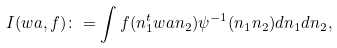<formula> <loc_0><loc_0><loc_500><loc_500>I ( w a , f ) \colon = \int f ( n _ { 1 } ^ { t } w a n _ { 2 } ) \psi ^ { - 1 } ( n _ { 1 } n _ { 2 } ) d n _ { 1 } d n _ { 2 } ,</formula> 